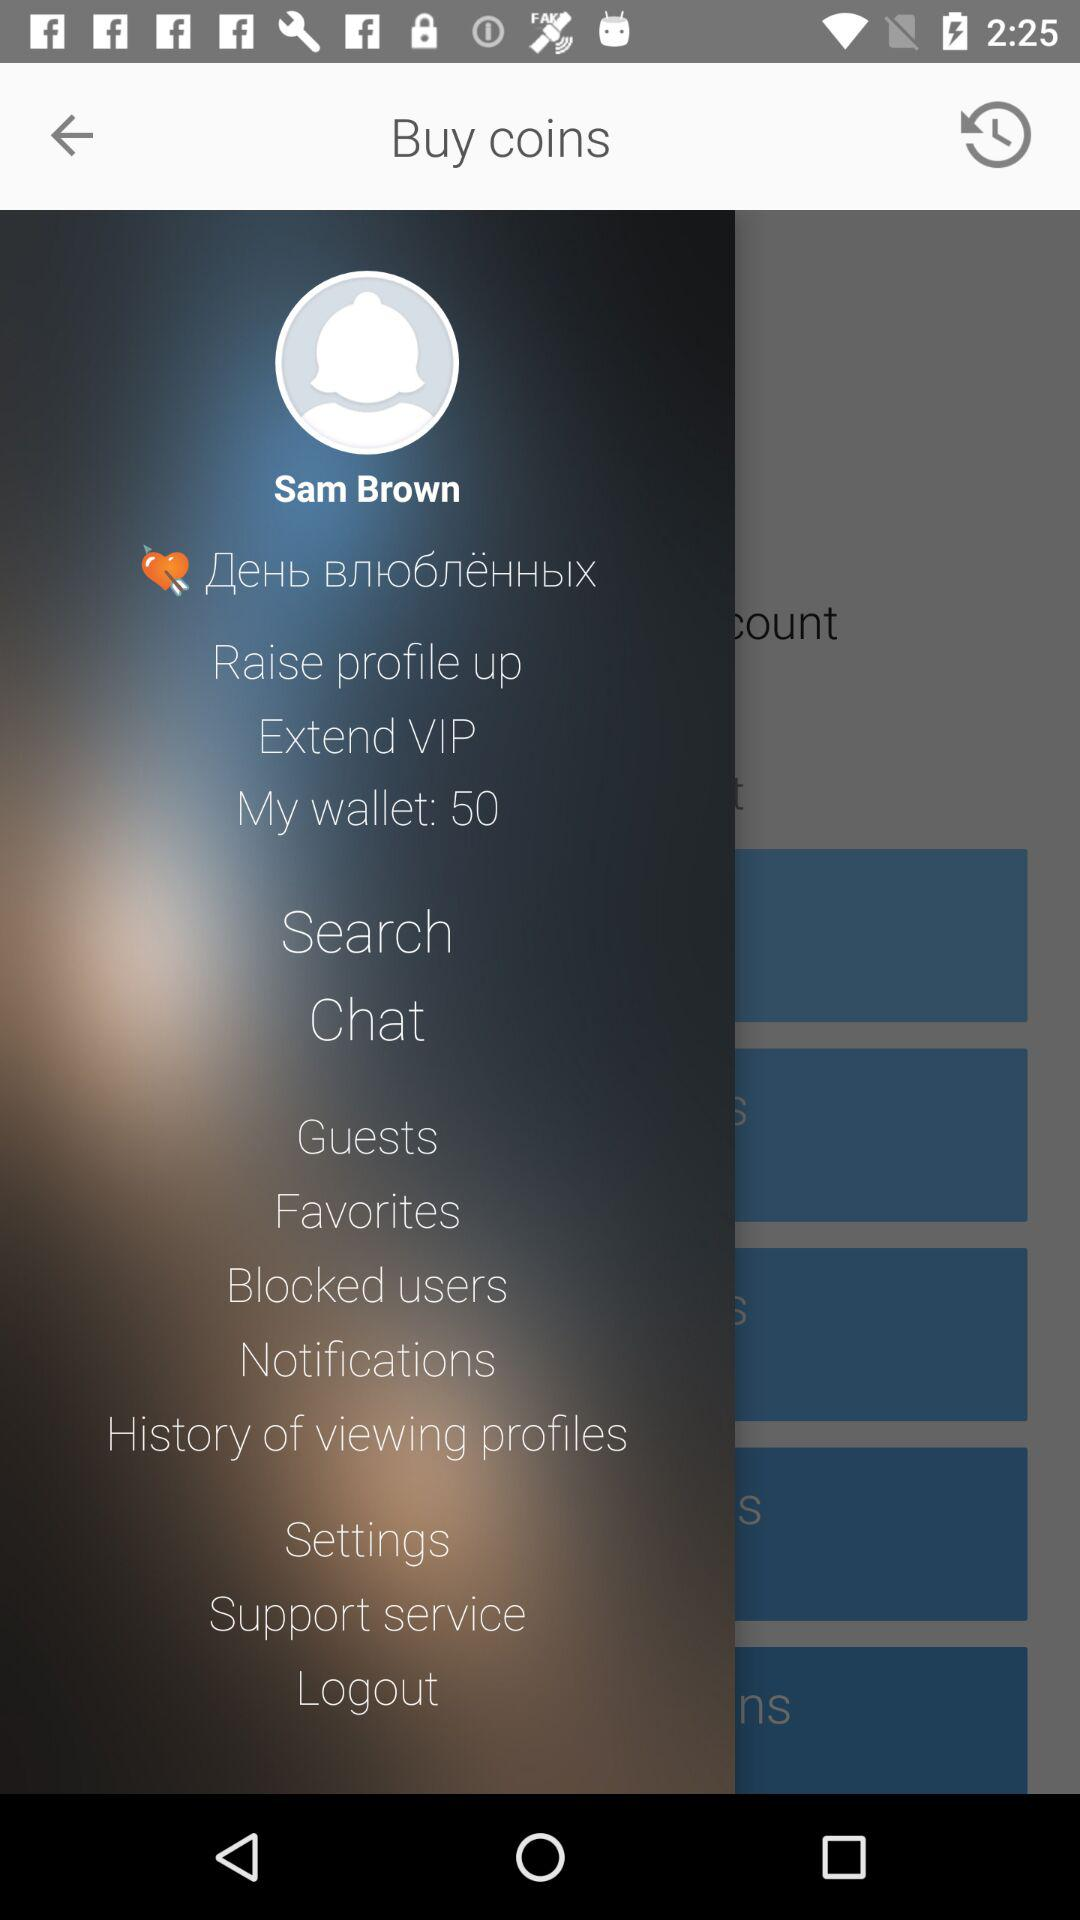What is the profile name? The profile name is Sam Brown. 